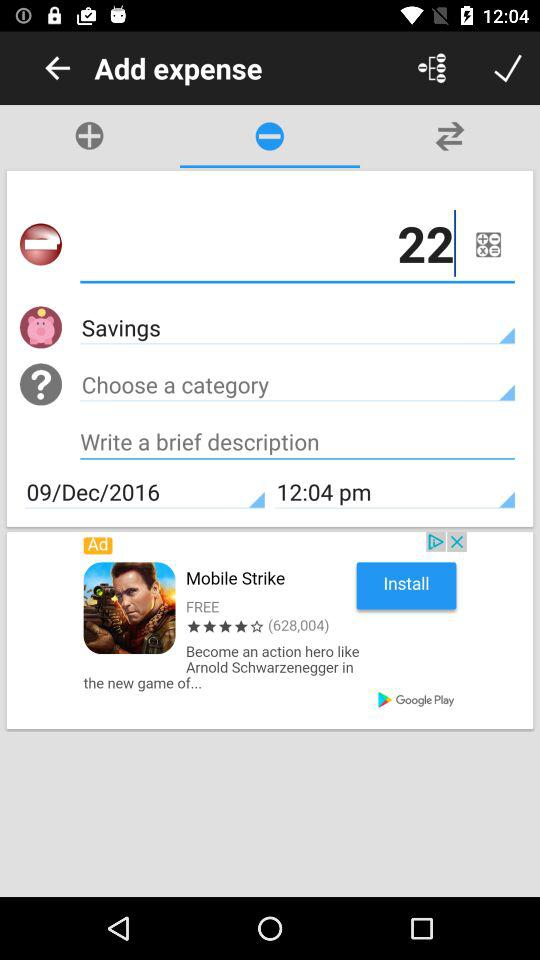What is the time? The time is 12:04 p.m. 